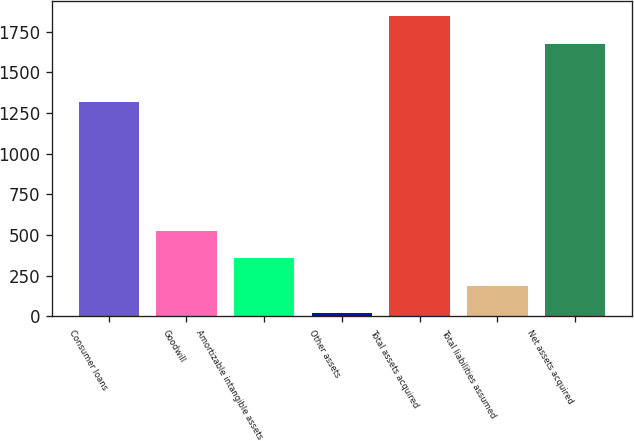<chart> <loc_0><loc_0><loc_500><loc_500><bar_chart><fcel>Consumer loans<fcel>Goodwill<fcel>Amortizable intangible assets<fcel>Other assets<fcel>Total assets acquired<fcel>Total liabilities assumed<fcel>Net assets acquired<nl><fcel>1316<fcel>525.8<fcel>357.2<fcel>20<fcel>1844.6<fcel>188.6<fcel>1676<nl></chart> 